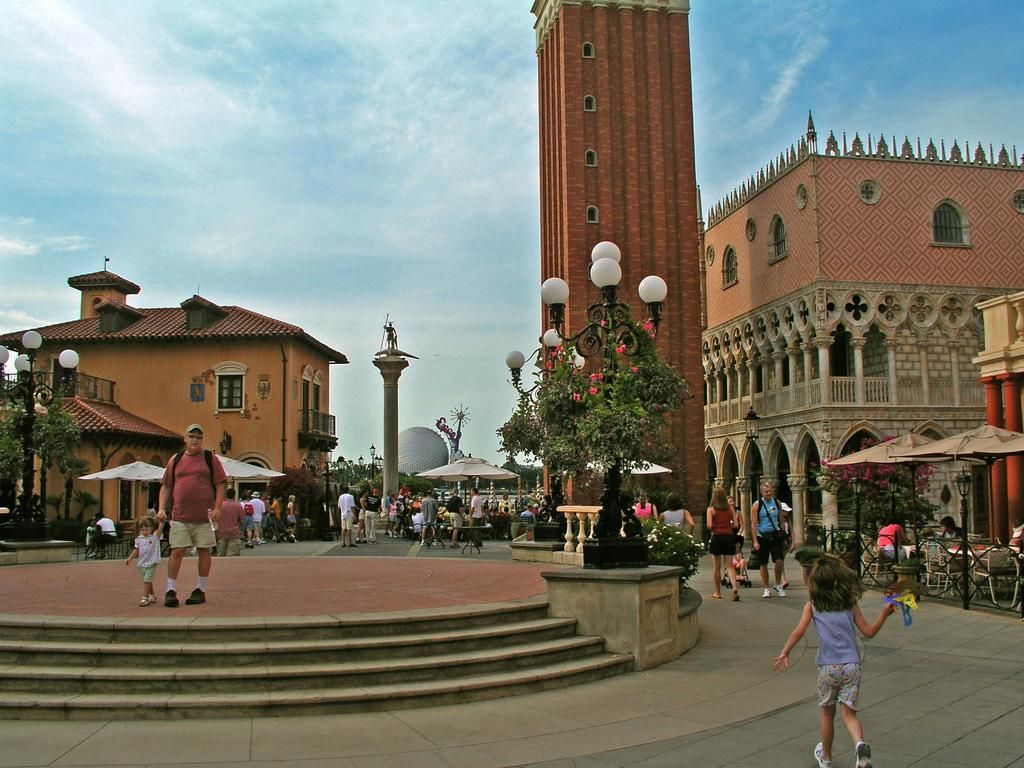How many people are in the image? There is a group of people in the image, but the exact number is not specified. What can be seen in the background of the image? There are buildings in the background of the image. What songs are being sung by the people in the image? There is no information about songs being sung in the image. 